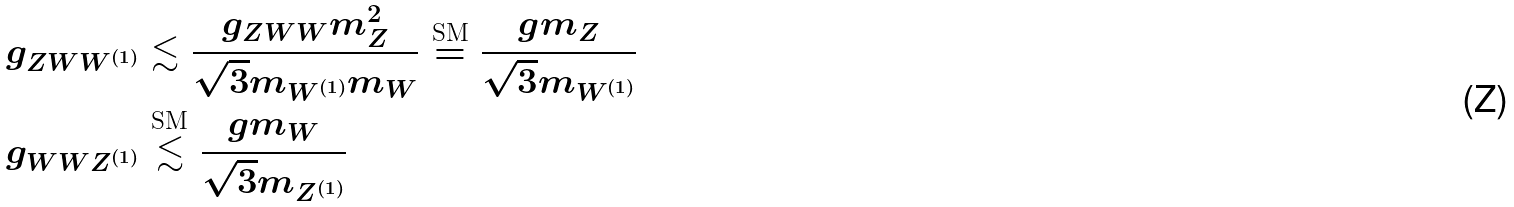Convert formula to latex. <formula><loc_0><loc_0><loc_500><loc_500>g _ { Z W W ^ { ( 1 ) } } & \lesssim \frac { g _ { Z W W } m _ { Z } ^ { 2 } } { \sqrt { 3 } m _ { W ^ { ( 1 ) } } m _ { W } } \overset { \text {SM} } { = } \frac { g m _ { Z } } { \sqrt { 3 } m _ { W ^ { ( 1 ) } } } \\ g _ { W W Z ^ { ( 1 ) } } & \overset { \text {SM} } { \lesssim } \frac { g m _ { W } } { \sqrt { 3 } m _ { Z ^ { ( 1 ) } } }</formula> 